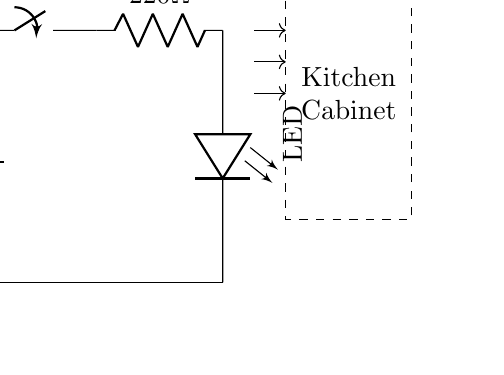What is the voltage of this circuit? The voltage of the circuit is 3 volts, which is indicated by the battery label in the circuit diagram. It's important to identify the power supply component to determine the voltage.
Answer: 3 volts What kind of switch is used in this circuit? The switch in the circuit is an on/off switch, as indicated by the label next to it. The orientation (vertical) and label specify its function.
Answer: On/off How many components are connected in series in this circuit? There are three components connected in series: the battery, the switch, and the resistor. This is determined by following the connection path from the battery to the LED.
Answer: Three What is the resistance value used in this circuit? The resistance value is 220 ohms, as shown next to the resistor in the circuit diagram. Identifying the labeled values of each component leads to the answer.
Answer: 220 ohms What is the purpose of the resistor in this circuit? The purpose of the resistor is to limit the current flowing to the LED, as LEDs require a specific current to function properly without burning out. Understanding the role of each component helps in answering this question.
Answer: Limit current What does the dashed rectangle represent in the circuit? The dashed rectangle represents the kitchen cabinet, which is visually marked in the diagram. It indicates the area where the LED will illuminate, serving as the context for the circuit's application.
Answer: Kitchen cabinet What happens when the switch is turned off? When the switch is turned off, the circuit is broken, preventing current from flowing through the circuit and turning off the LED. This follows from the basic principle that an open switch disrupts circuit continuity.
Answer: LED turns off 